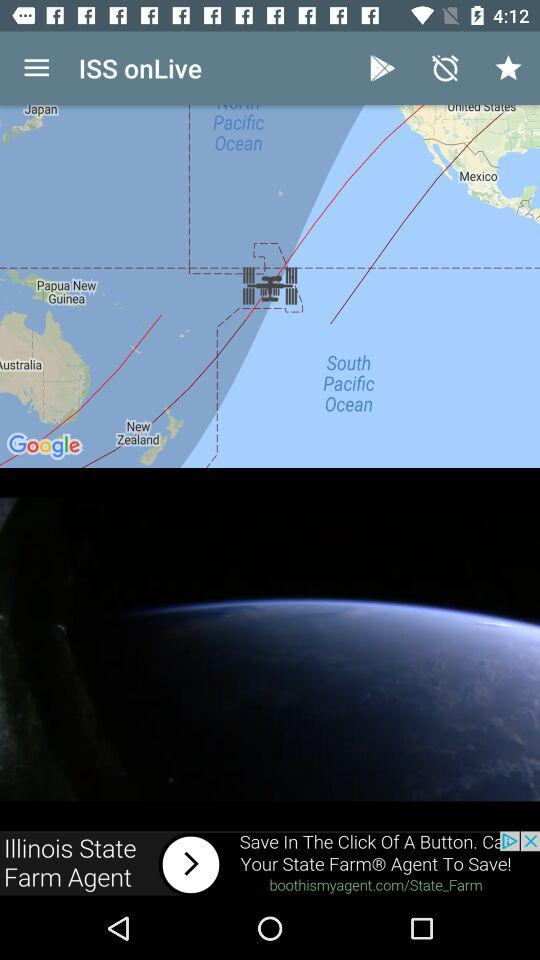What version is available? The available version is 2.4.15. 